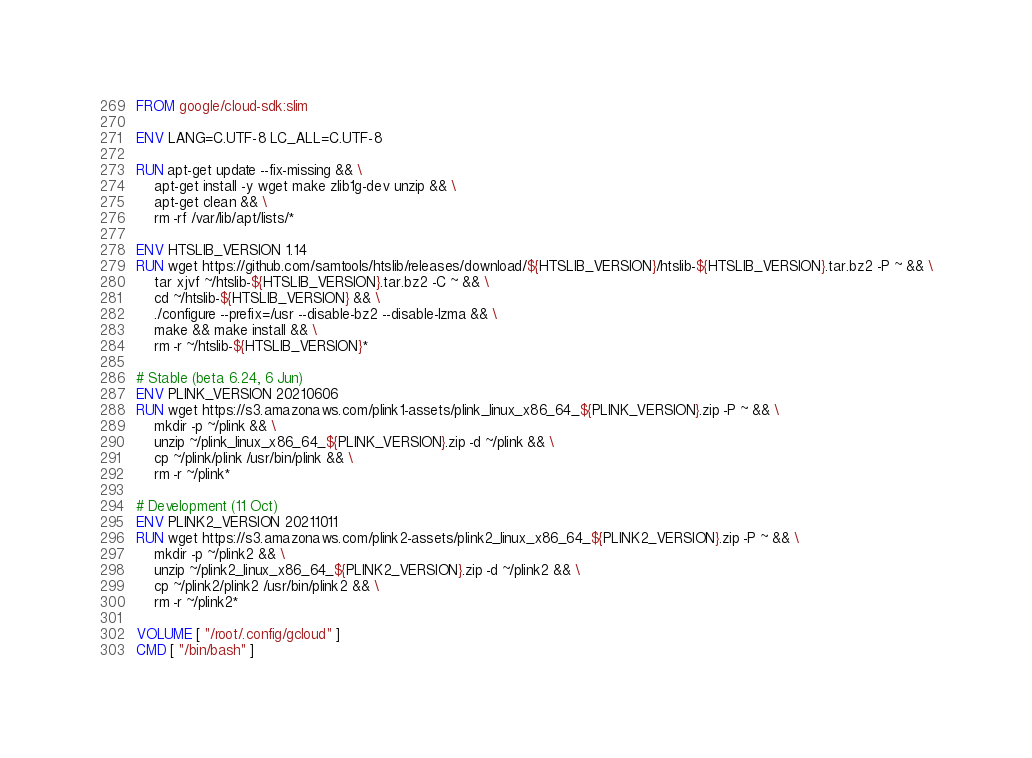<code> <loc_0><loc_0><loc_500><loc_500><_Dockerfile_>FROM google/cloud-sdk:slim

ENV LANG=C.UTF-8 LC_ALL=C.UTF-8

RUN apt-get update --fix-missing && \
    apt-get install -y wget make zlib1g-dev unzip && \
    apt-get clean && \
    rm -rf /var/lib/apt/lists/*

ENV HTSLIB_VERSION 1.14
RUN wget https://github.com/samtools/htslib/releases/download/${HTSLIB_VERSION}/htslib-${HTSLIB_VERSION}.tar.bz2 -P ~ && \
    tar xjvf ~/htslib-${HTSLIB_VERSION}.tar.bz2 -C ~ && \
    cd ~/htslib-${HTSLIB_VERSION} && \
    ./configure --prefix=/usr --disable-bz2 --disable-lzma && \
    make && make install && \
    rm -r ~/htslib-${HTSLIB_VERSION}*

# Stable (beta 6.24, 6 Jun)
ENV PLINK_VERSION 20210606
RUN wget https://s3.amazonaws.com/plink1-assets/plink_linux_x86_64_${PLINK_VERSION}.zip -P ~ && \
    mkdir -p ~/plink && \
    unzip ~/plink_linux_x86_64_${PLINK_VERSION}.zip -d ~/plink && \
    cp ~/plink/plink /usr/bin/plink && \
    rm -r ~/plink*

# Development (11 Oct)
ENV PLINK2_VERSION 20211011
RUN wget https://s3.amazonaws.com/plink2-assets/plink2_linux_x86_64_${PLINK2_VERSION}.zip -P ~ && \
    mkdir -p ~/plink2 && \
    unzip ~/plink2_linux_x86_64_${PLINK2_VERSION}.zip -d ~/plink2 && \
    cp ~/plink2/plink2 /usr/bin/plink2 && \
    rm -r ~/plink2*

VOLUME [ "/root/.config/gcloud" ]
CMD [ "/bin/bash" ]
</code> 